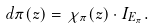<formula> <loc_0><loc_0><loc_500><loc_500>d \pi ( z ) = \chi _ { \pi } ( z ) \cdot I _ { E _ { \pi } } .</formula> 